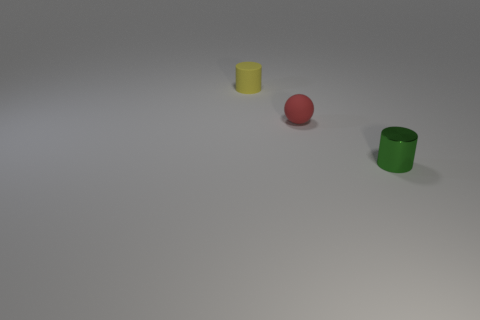Add 3 red matte things. How many objects exist? 6 Subtract all cylinders. How many objects are left? 1 Add 1 small yellow things. How many small yellow things exist? 2 Subtract 0 red cylinders. How many objects are left? 3 Subtract all tiny green objects. Subtract all matte cylinders. How many objects are left? 1 Add 2 small yellow matte things. How many small yellow matte things are left? 3 